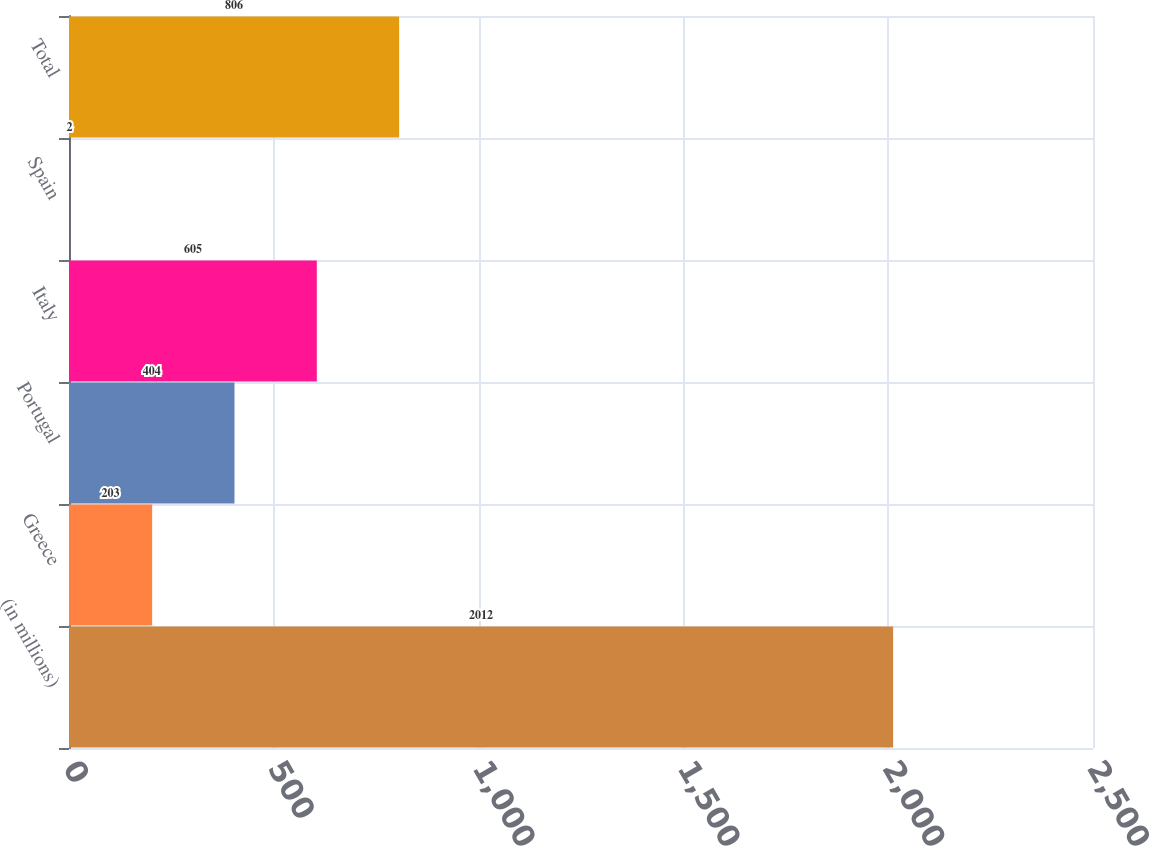Convert chart to OTSL. <chart><loc_0><loc_0><loc_500><loc_500><bar_chart><fcel>(in millions)<fcel>Greece<fcel>Portugal<fcel>Italy<fcel>Spain<fcel>Total<nl><fcel>2012<fcel>203<fcel>404<fcel>605<fcel>2<fcel>806<nl></chart> 